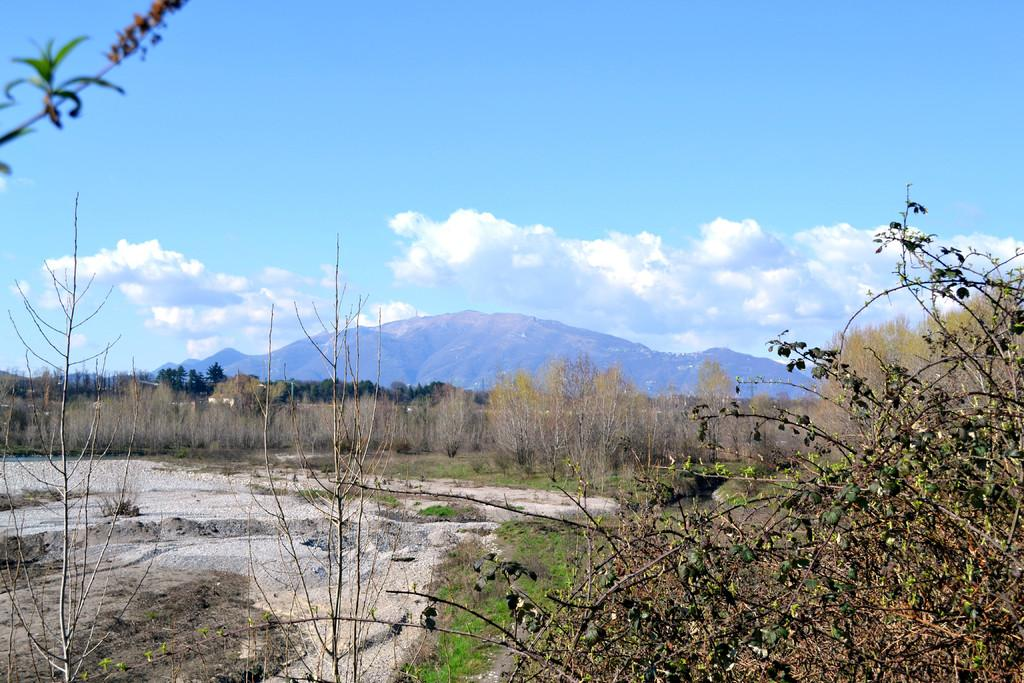What is present at the bottom of the image? There are plants and grass at the bottom of the image. What can be found in the middle of the image? There are plants, trees, hills, and the sky visible in the middle of the image. Can you describe the clouds in the image? Yes, there are clouds in the middle of the image. What type of road can be seen in the image? There is no road present in the image. Is there a ladybug on any of the plants in the image? There is no mention of a ladybug in the provided facts, so it cannot be determined if one is present in the image. 